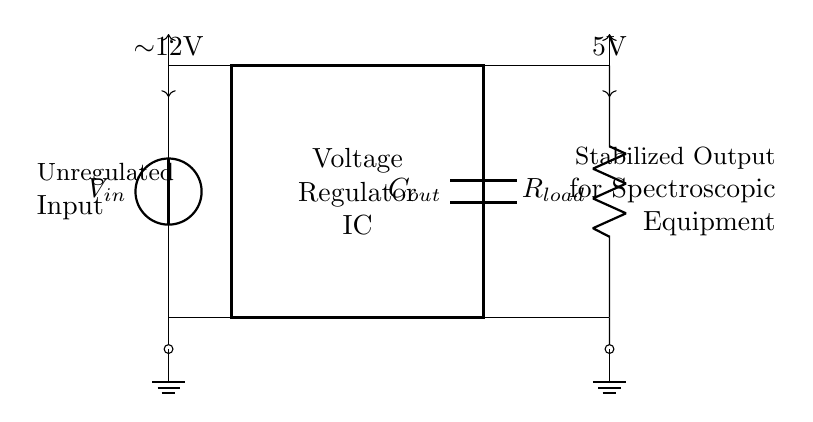What is the input voltage of the circuit? The input voltage is indicated at the vsource as approximately 12V, which is shown in the diagram with a voltage arrow.
Answer: 12V What is the output voltage supplied to the spectroscopic equipment? The output voltage is 5V, as indicated in the circuit diagram, shown by the voltage arrow at the output side.
Answer: 5V What component stabilizes the output voltage? The component responsible for stabilizing the output voltage is the voltage regulator IC, which is labeled within the rectangle in the circuit diagram.
Answer: Voltage Regulator IC What type of capacitor is used at the output? The component labeled as "Cout" in the diagram is an output capacitor, which provides stabilization to the voltage output of the regulator.
Answer: Output Capacitor What is the role of resistance in this circuit? The resistor labeled as "Rload" represents the load resistance connected at the output to simulate actual load conditions for the spectroscopic equipment.
Answer: Load Resistance How does the voltage regulator change input to output voltage? The voltage regulator adjusts the higher unregulated input voltage (12V) to a lower regulated output voltage (5V) by maintaining a constant voltage level despite variations in input or load conditions.
Answer: By regulating voltage What is the primary purpose of this voltage regulator circuit? The primary purpose of this voltage regulator circuit is to provide a stable and consistent 5V power supply to the spectroscopic equipment, ensuring proper functionality without voltage fluctuations.
Answer: Stabilize Power Supply 